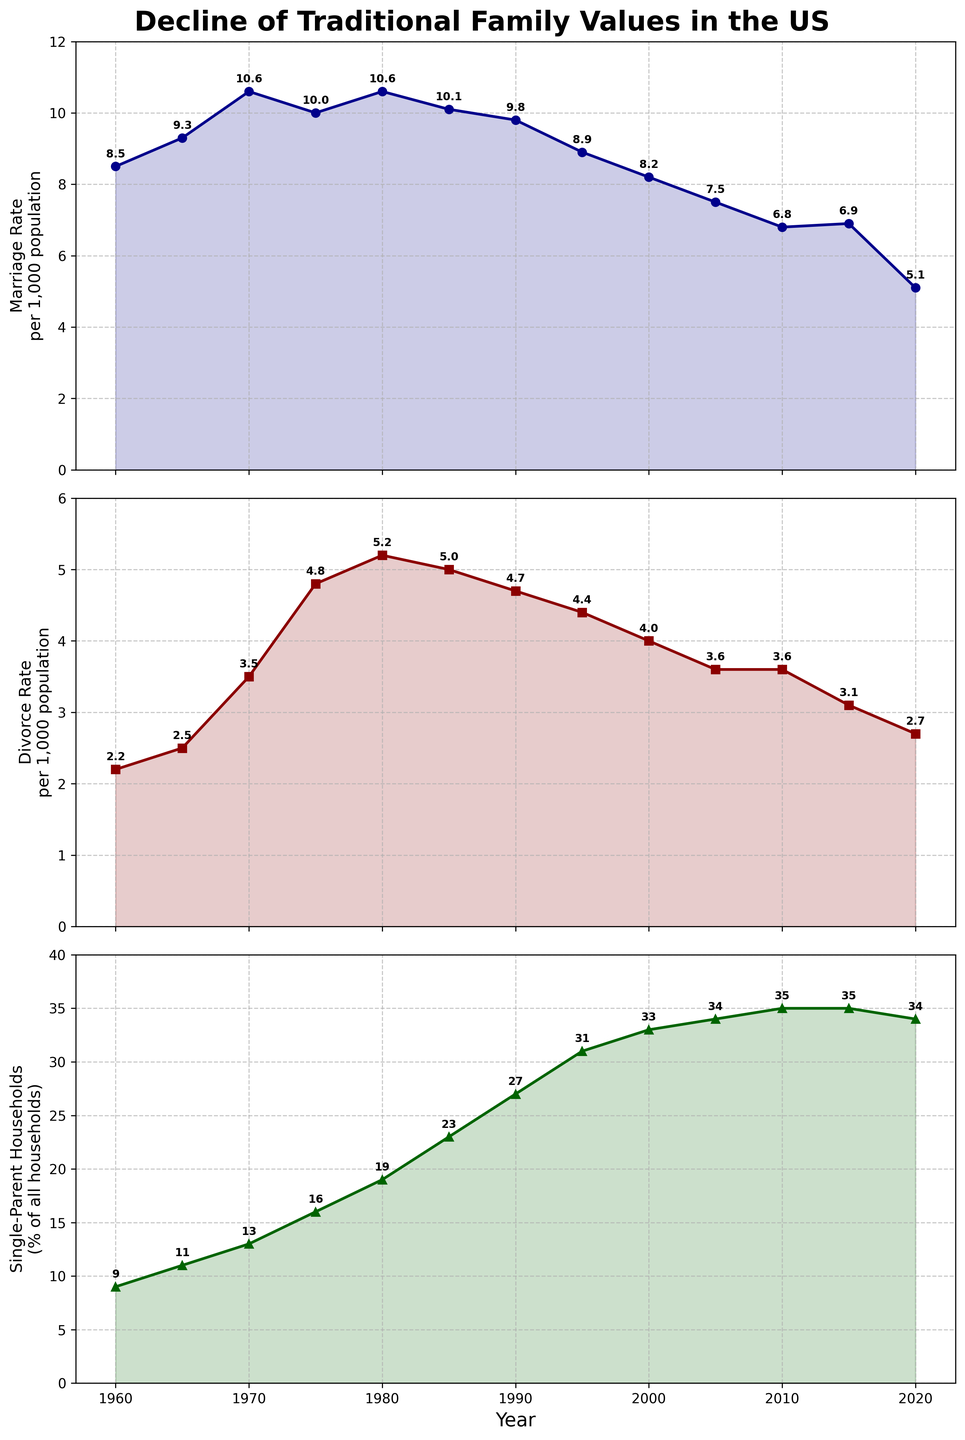What year had the highest marriage rate? Look at the line representing Marriage Rate and identify the peak point. The highest point occurs in 1970, where the rate is 10.6.
Answer: 1970 By how much did the divorce rate increase from 1960 to 1980? Find the Divorce Rate for 1960 (2.2) and 1980 (5.2). Subtract the 1960 rate from the 1980 rate: 5.2 - 2.2 = 3.0.
Answer: 3.0 Which year had the smallest percentage of single-parent households? Check the line representing Single-Parent Households and identify the lowest point. The lowest value is in 1960, where the percentage is 9.
Answer: 1960 Compare the marriage rate in 2000 to that in 2020. Which was higher, and by how much? Identify the Marriage Rate for 2000 (8.2) and 2020 (5.1). Since 8.2 > 5.1, 2000 had a higher rate. Subtract the 2020 rate from the 2000 rate: 8.2 - 5.1 = 3.1.
Answer: 2000, by 3.1 What is the average percentage of single-parent households in the years 2005, 2010, and 2015? Find the values for Single-Parent Households in 2005 (34), 2010 (35), and 2015 (35). Sum these values: 34 + 35 + 35 = 104. Divide by the number of years: 104 / 3 = 34.67.
Answer: 34.67 In which decade did the divorce rate peak? Observe the Divorce Rate line to find the highest point, which is in 1980 with a rate of 5.2. Therefore, the peak occurred in the 1980s decade.
Answer: 1980s Between 1985 and 1995, how did the Marriage Rate and Divorce Rate change? Find the Marriage Rate for 1985 (10.1) and 1995 (8.9) and find the change: 8.9 - 10.1 = -1.2 (decrease). Find the Divorce Rate for 1985 (5.0) and 1995 (4.4) and find the change: 4.4 - 5.0 = -0.6 (decrease).
Answer: Marriage Rate: decreased by 1.2; Divorce Rate: decreased by 0.6 How many years did the Single-Parent Households percentage remain the same between 2010 and 2020? From the line for Single-Parent Households, the percentage is 35 in 2010 and 2015, but changes to 34 in 2020, thus stayed consistent for two observations (2010 and 2015).
Answer: 2 years 